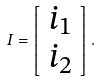Convert formula to latex. <formula><loc_0><loc_0><loc_500><loc_500>I = \left [ \begin{array} { c } i _ { 1 } \\ i _ { 2 } \end{array} \right ] .</formula> 